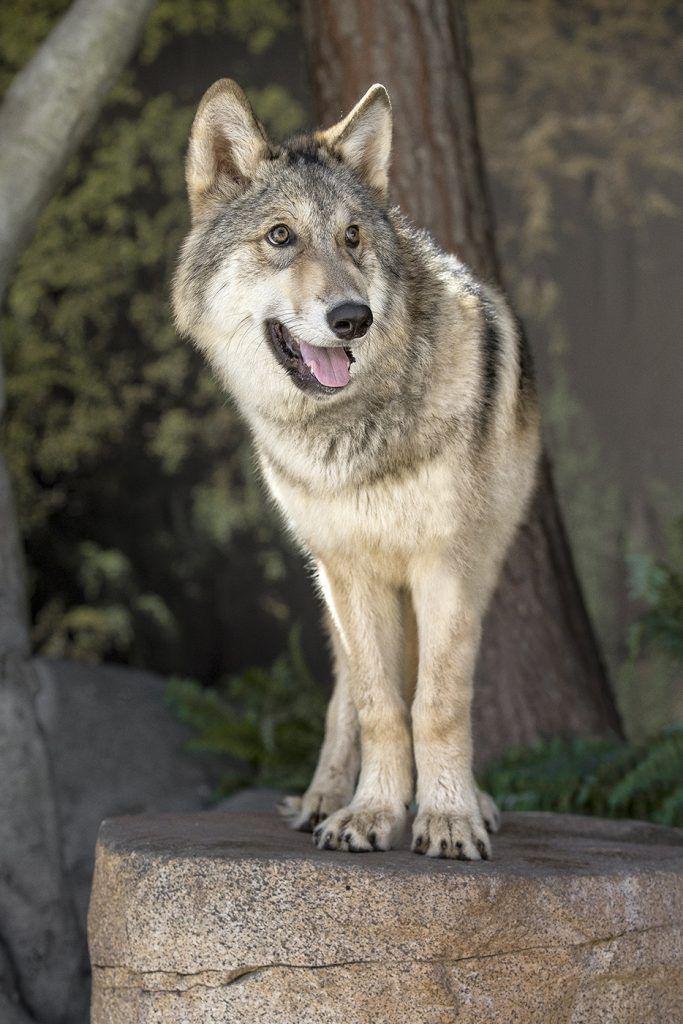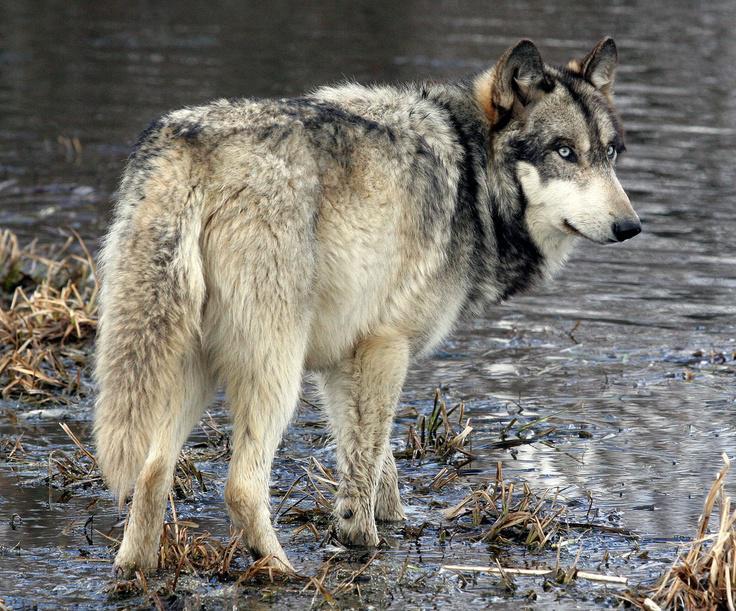The first image is the image on the left, the second image is the image on the right. Evaluate the accuracy of this statement regarding the images: "There is exactly one animal with its mouth open in one of the images.". Is it true? Answer yes or no. Yes. 